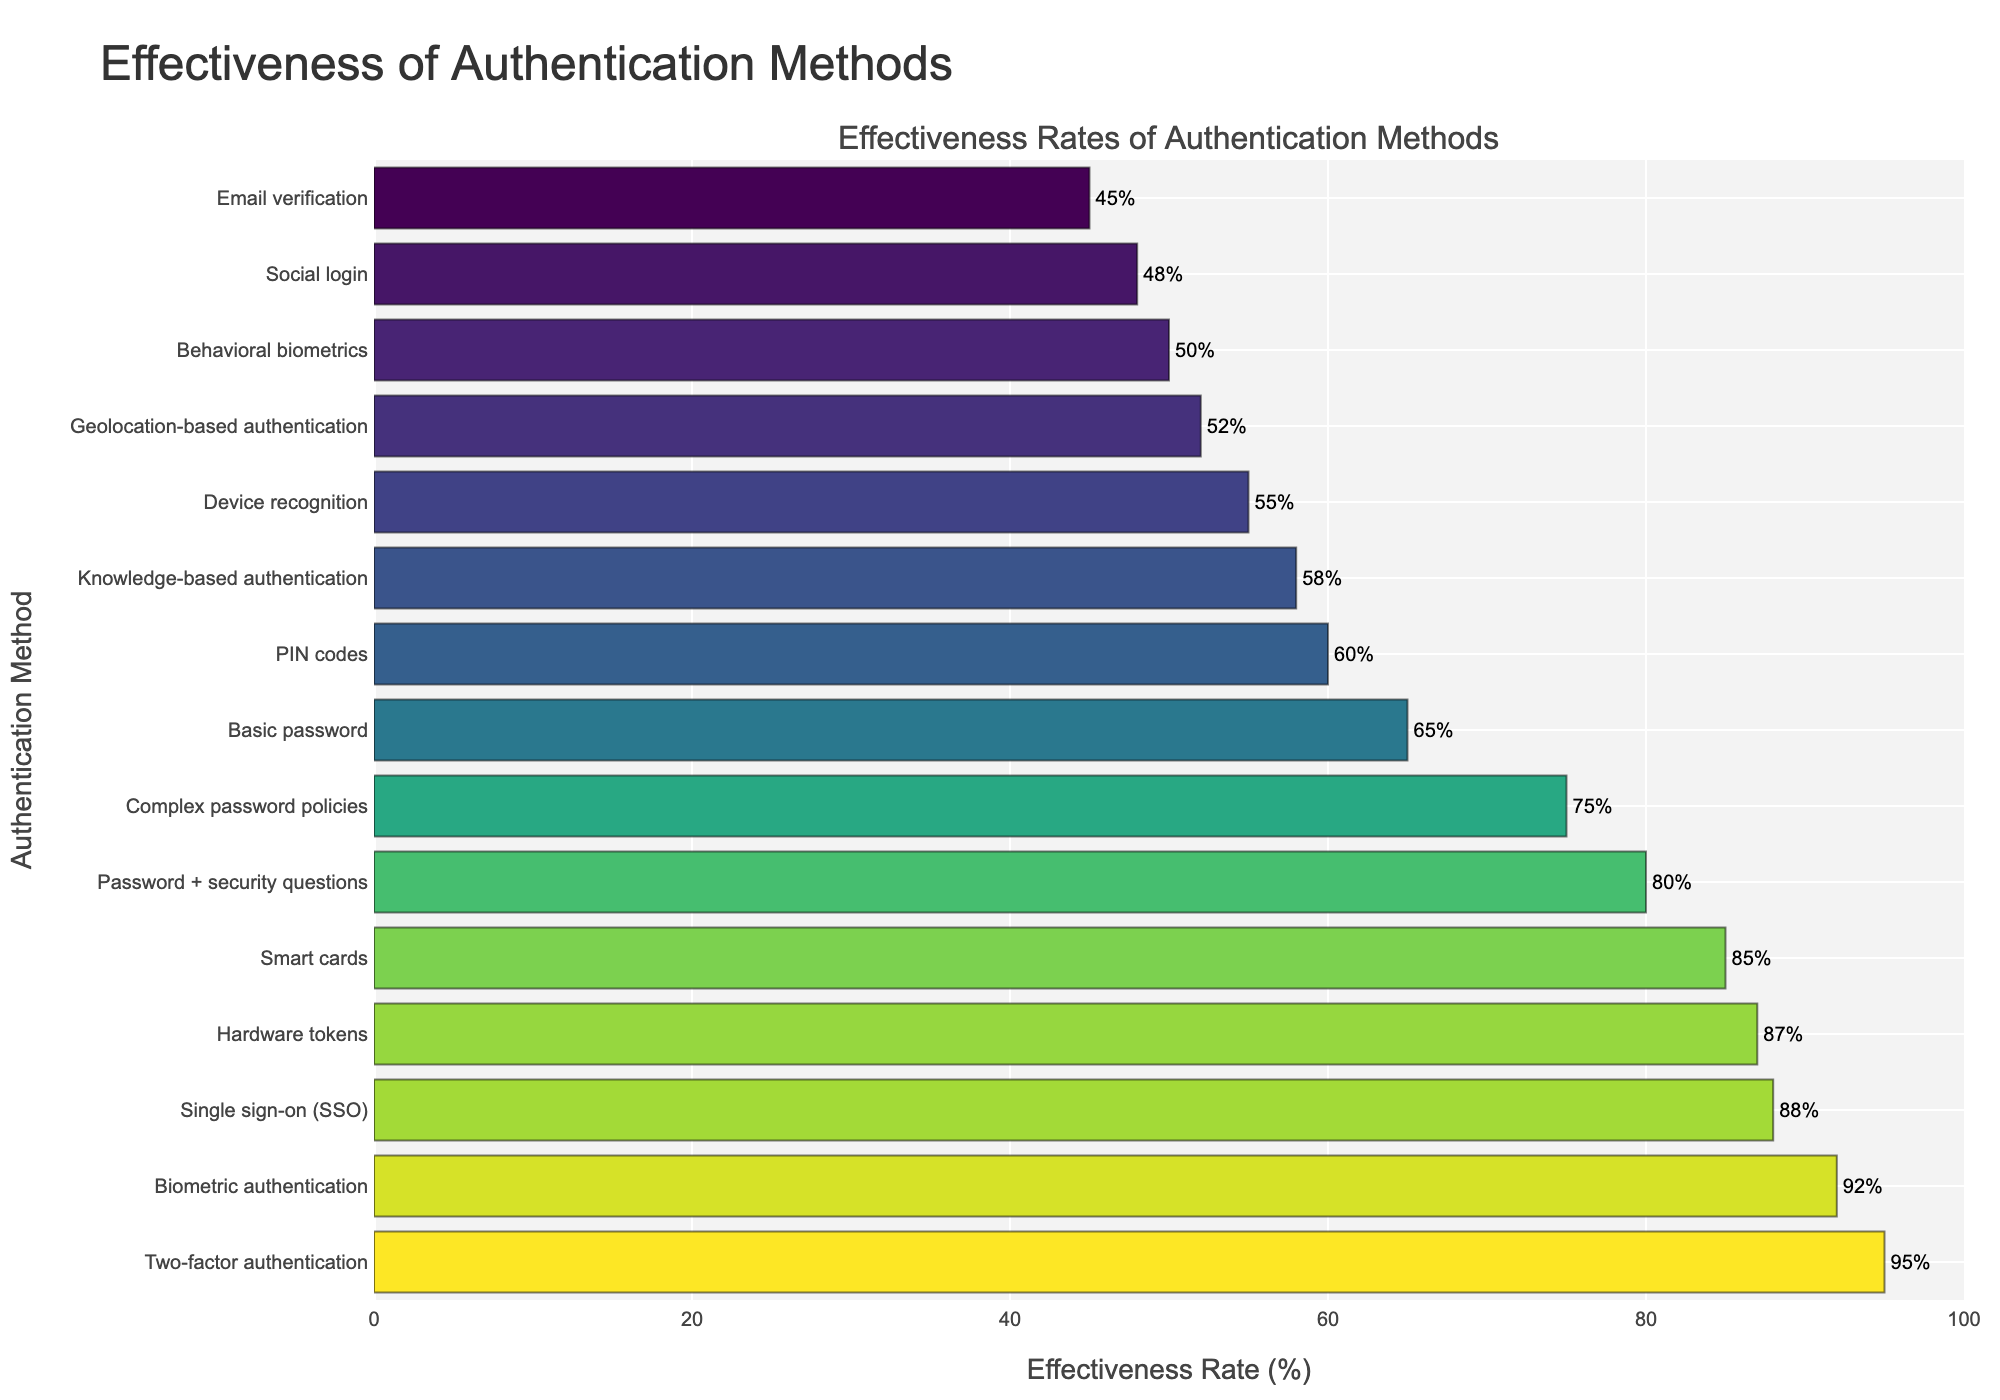Which authentication method has the highest effectiveness rate? The bar chart shows the effectiveness rates of various authentication methods. By identifying the tallest bar on the chart, we can determine the method with the highest rate.
Answer: Two-factor authentication How much more effective is Biometric authentication compared to Device recognition? To find the difference, we look at the effectiveness rates of Biometric authentication (92%) and Device recognition (55%), then subtract the latter from the former: 92% - 55% = 37%.
Answer: 37% Which authentication method is less effective, Complex password policies or PIN codes? The shorter the bar, the less effective the method. By comparing the bar lengths, we see PIN codes (60%) have a shorter bar than Complex password policies (75%).
Answer: PIN codes What is the combined effectiveness rate of Single sign-on, Hardware tokens, and Smart cards? We sum the effectiveness rates of Single sign-on (88%), Hardware tokens (87%), and Smart cards (85%): 88% + 87% + 85% = 260%.
Answer: 260% Is Geolocation-based authentication more effective than Behavioral biometrics? By comparing the bar lengths, Geolocation-based authentication (52%) is taller than Behavioral biometrics (50%).
Answer: Yes Which method is the least effective, and what is its rate? The shortest bar indicates the least effective method, which is Email verification with a rate of 45%.
Answer: Email verification, 45% How many methods have an effectiveness rate above 80%? Count the bars that reach or extend above the 80% mark. There are six methods above 80% (Two-factor authentication, Biometric authentication, Single sign-on, Hardware tokens, Smart cards, Password + security questions).
Answer: 6 What's the difference in effectiveness between the most and least effective methods? Subtract the effectiveness rate of the least effective method (Email verification, 45%) from the most effective method (Two-factor authentication, 95%): 95% - 45% = 50%.
Answer: 50% Which has a higher effectiveness rate: Knowledge-based authentication or Geolocation-based authentication? By comparing the bar lengths, Geolocation-based authentication (52%) is taller than Knowledge-based authentication (58%).
Answer: Knowledge-based authentication What is the average effectiveness rate of the top three methods? First, identify the top three methods by effectiveness: Two-factor authentication (95%), Biometric authentication (92%), Single sign-on (88%). Then, average these values: (95% + 92% + 88%) / 3 = 91.67%.
Answer: 91.67% 